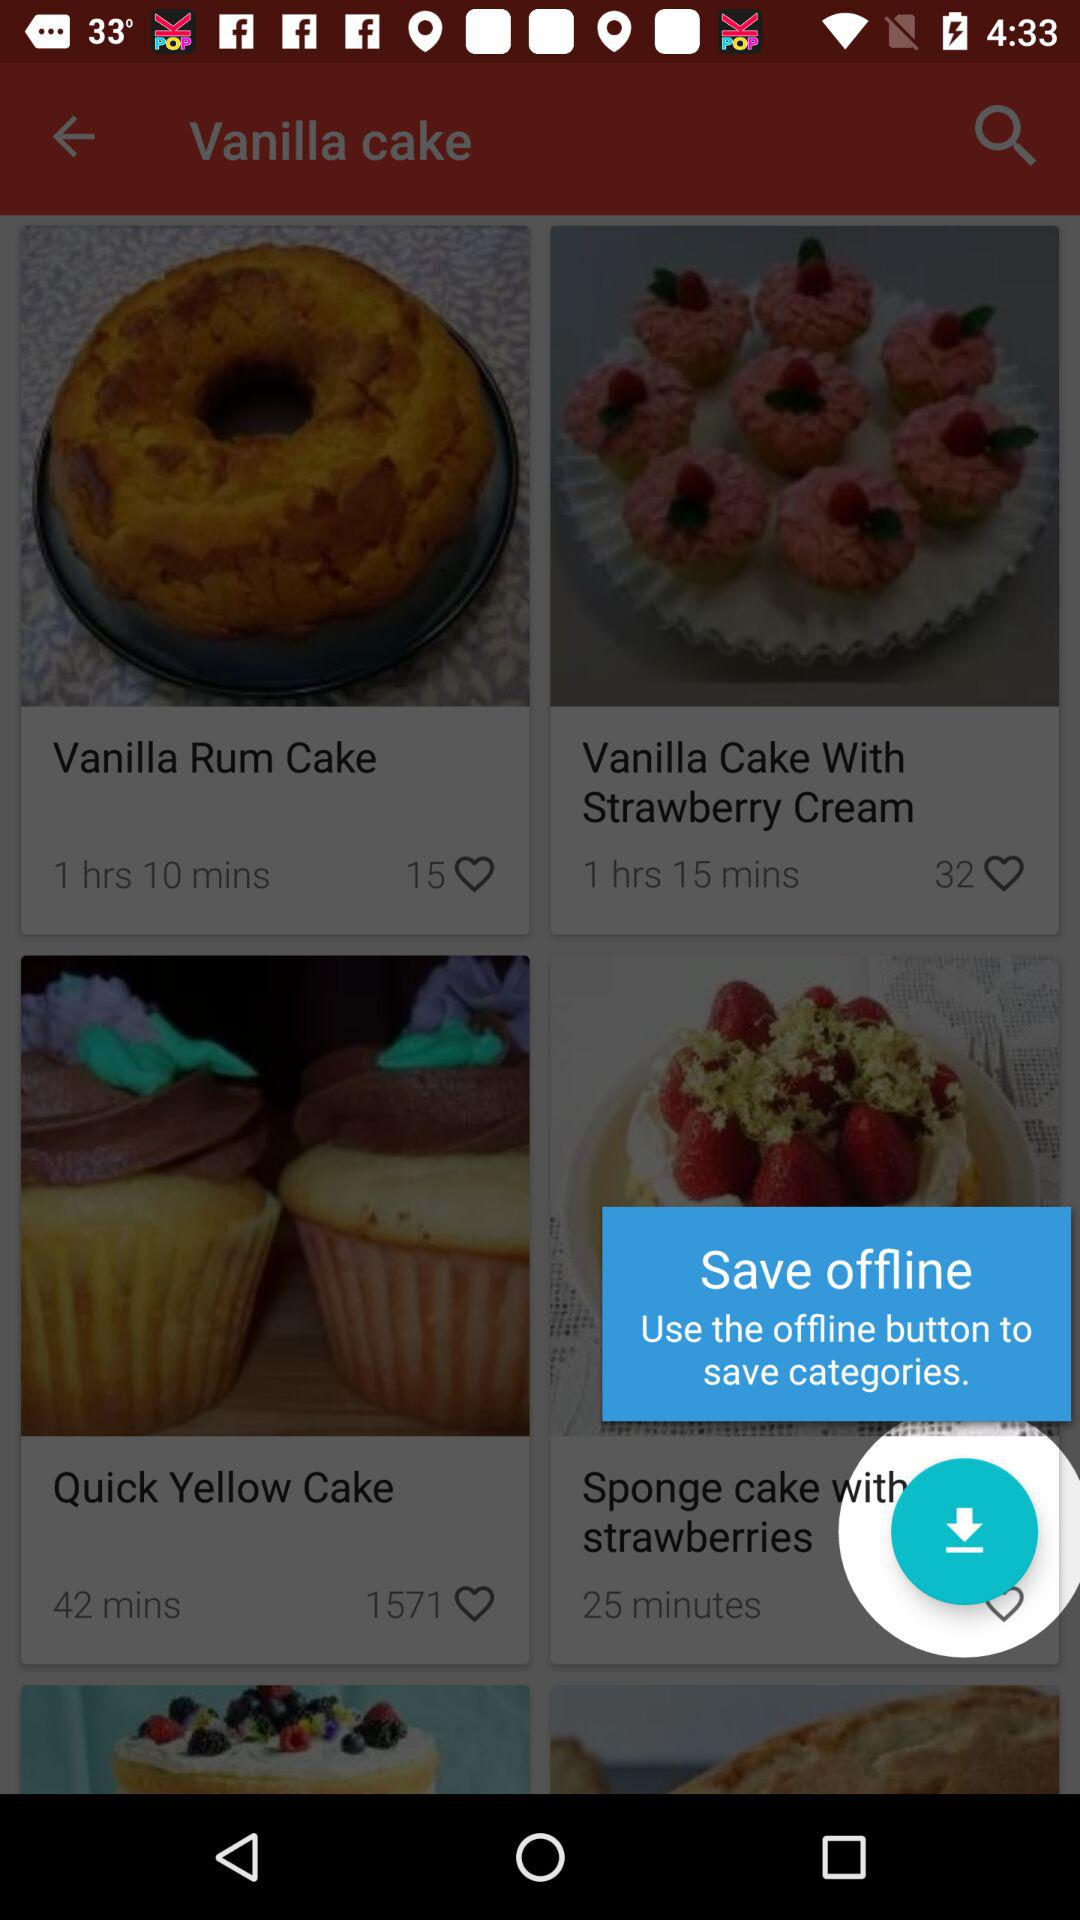How many likes did "Quick Yellow Cake" get? "Quick Yellow Cake" got 1571 likes. 